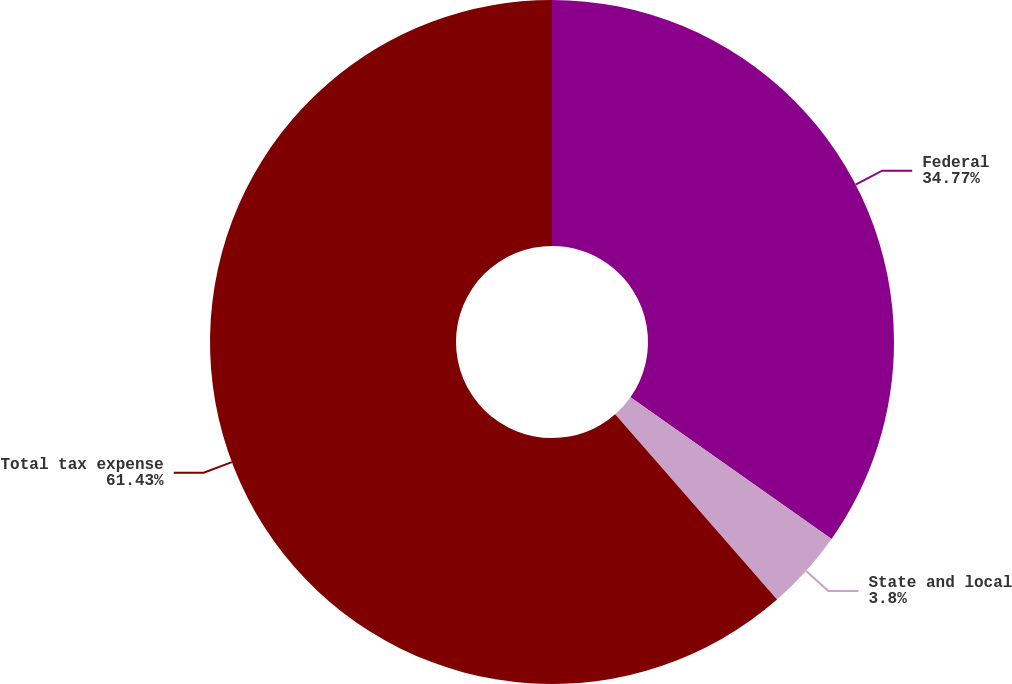<chart> <loc_0><loc_0><loc_500><loc_500><pie_chart><fcel>Federal<fcel>State and local<fcel>Total tax expense<nl><fcel>34.77%<fcel>3.8%<fcel>61.43%<nl></chart> 